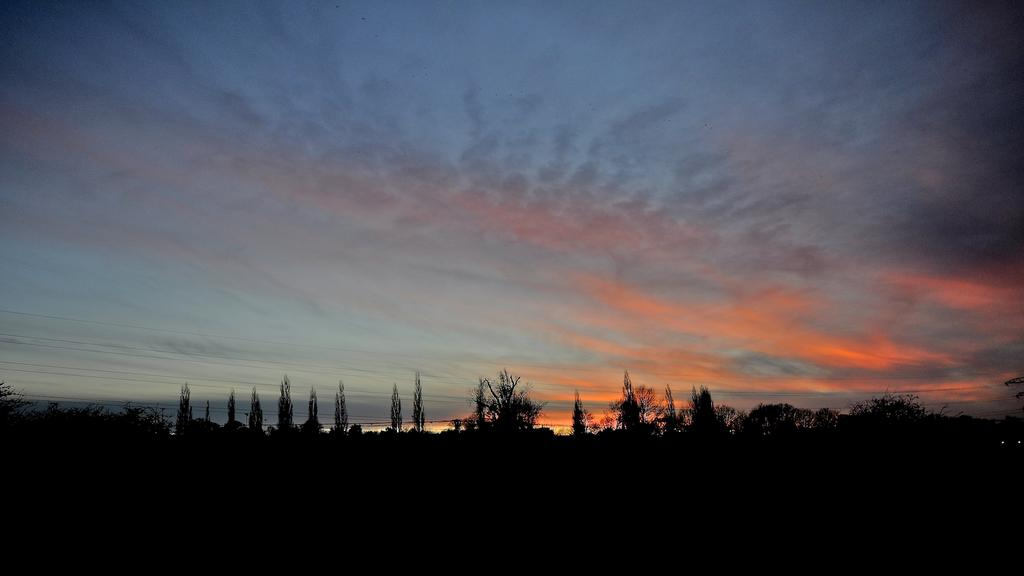What type of vegetation can be seen in the image? There is a group of trees in the image. What is the condition of the sky in the image? The sky is cloudy in the image. What type of powder is being applied to the flesh in the image? There is no powder or flesh present in the image; it features a group of trees and a cloudy sky. 